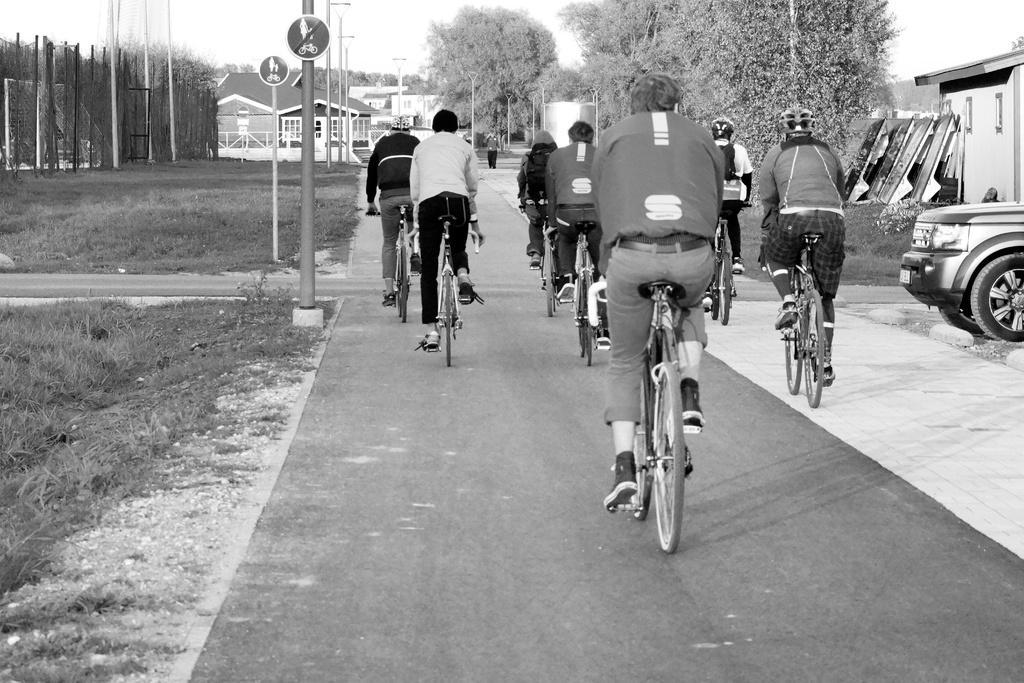Could you give a brief overview of what you see in this image? In this picture there are many people riding a bicycle on the road. In the right side there is a car parked. There is a pole here. In the background there are some trees open land and buildings. There is a sky too. 